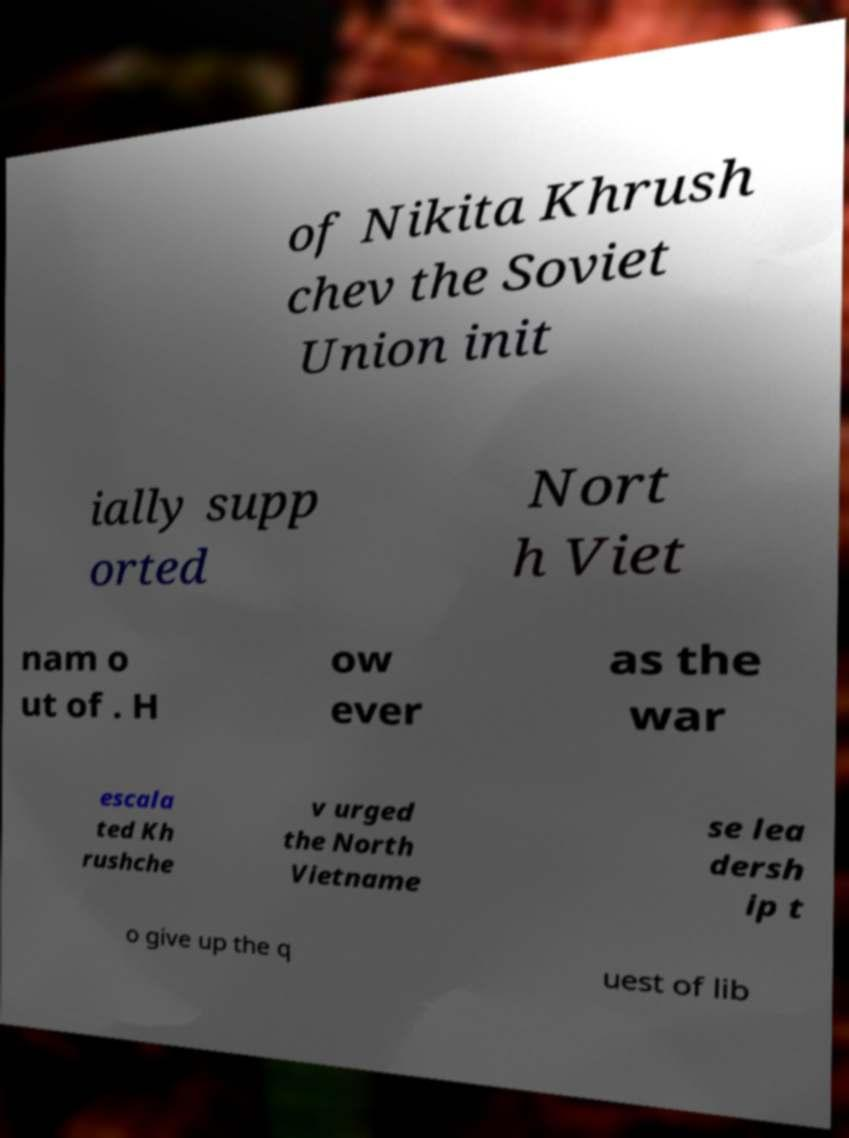There's text embedded in this image that I need extracted. Can you transcribe it verbatim? of Nikita Khrush chev the Soviet Union init ially supp orted Nort h Viet nam o ut of . H ow ever as the war escala ted Kh rushche v urged the North Vietname se lea dersh ip t o give up the q uest of lib 